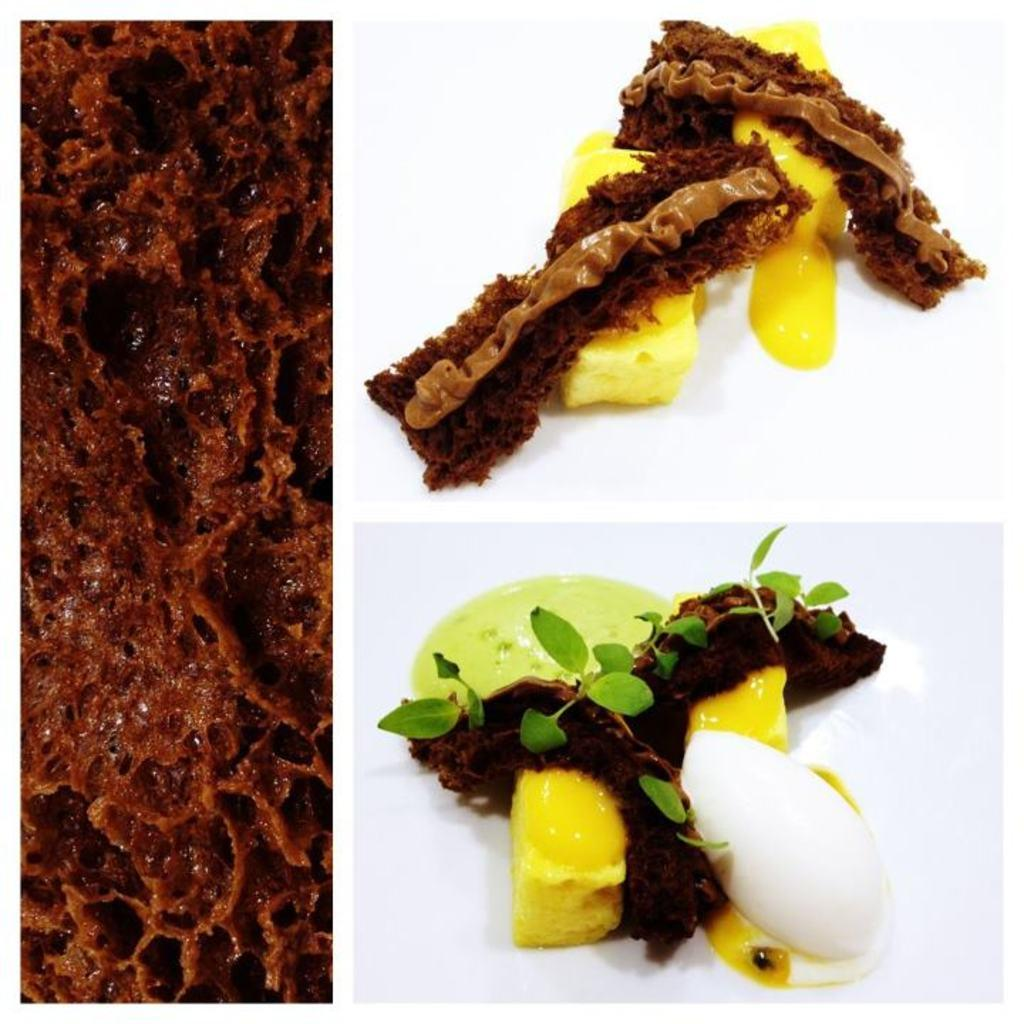What is the overall composition of the image? The image is a collage of different pictures. Can you describe any specific subjects or themes depicted in the collage? Some of the pictures in the collage depict food. What type of appliance can be seen in the image? There is no appliance present in the image; it is a collage of different pictures, some of which depict food. Is it raining in the image? There is no indication of rain in the image, as it is a collage of different pictures. 